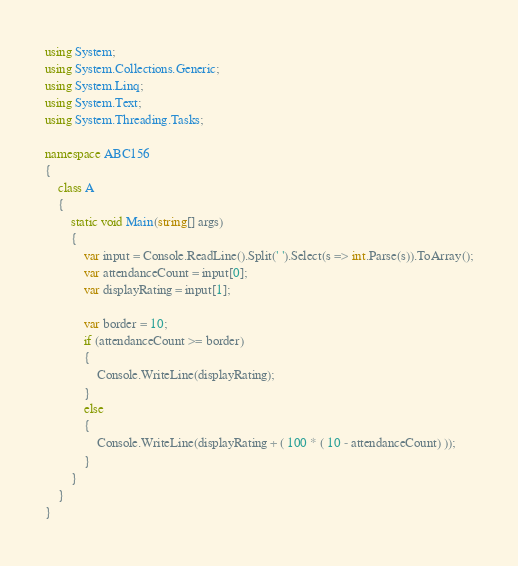Convert code to text. <code><loc_0><loc_0><loc_500><loc_500><_C#_>using System;
using System.Collections.Generic;
using System.Linq;
using System.Text;
using System.Threading.Tasks;

namespace ABC156
{
	class A
	{
		static void Main(string[] args)
		{
			var input = Console.ReadLine().Split(' ').Select(s => int.Parse(s)).ToArray();
			var attendanceCount = input[0];
			var displayRating = input[1];

			var border = 10;
			if (attendanceCount >= border)
			{
				Console.WriteLine(displayRating);
			}
			else
			{
				Console.WriteLine(displayRating + ( 100 * ( 10 - attendanceCount) ));
			}
		}
	}
}
</code> 